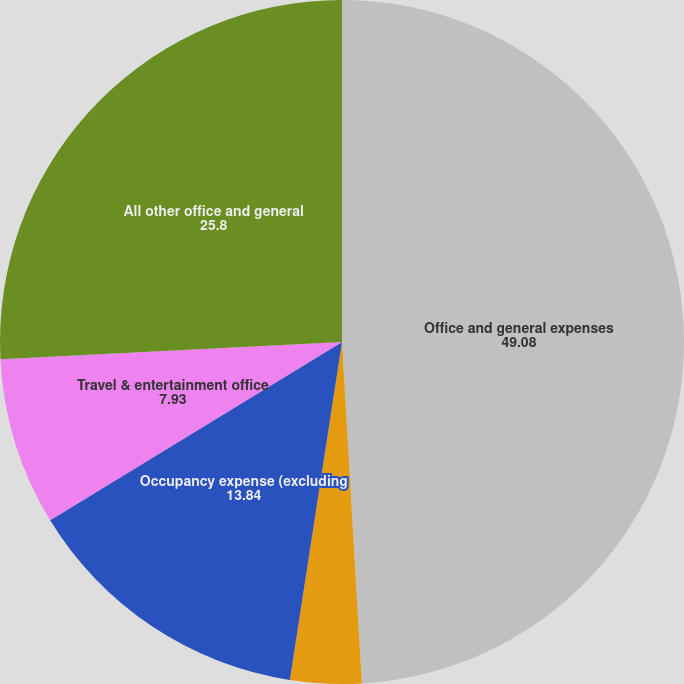<chart> <loc_0><loc_0><loc_500><loc_500><pie_chart><fcel>Office and general expenses<fcel>Professional fees<fcel>Occupancy expense (excluding<fcel>Travel & entertainment office<fcel>All other office and general<nl><fcel>49.08%<fcel>3.36%<fcel>13.84%<fcel>7.93%<fcel>25.8%<nl></chart> 